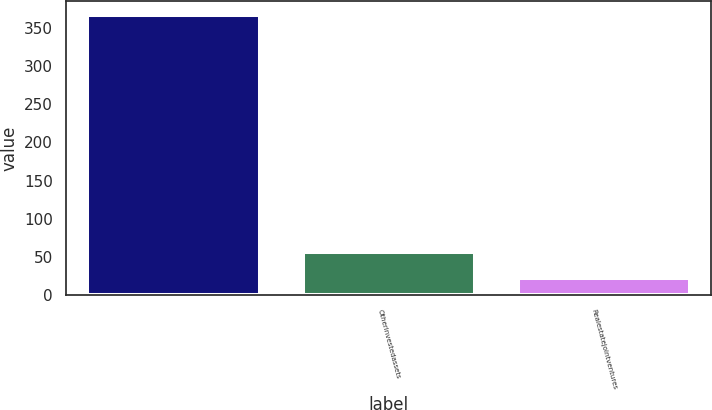Convert chart. <chart><loc_0><loc_0><loc_500><loc_500><bar_chart><ecel><fcel>Otherinvestedassets<fcel>Realestatejointventures<nl><fcel>367<fcel>56.5<fcel>22<nl></chart> 